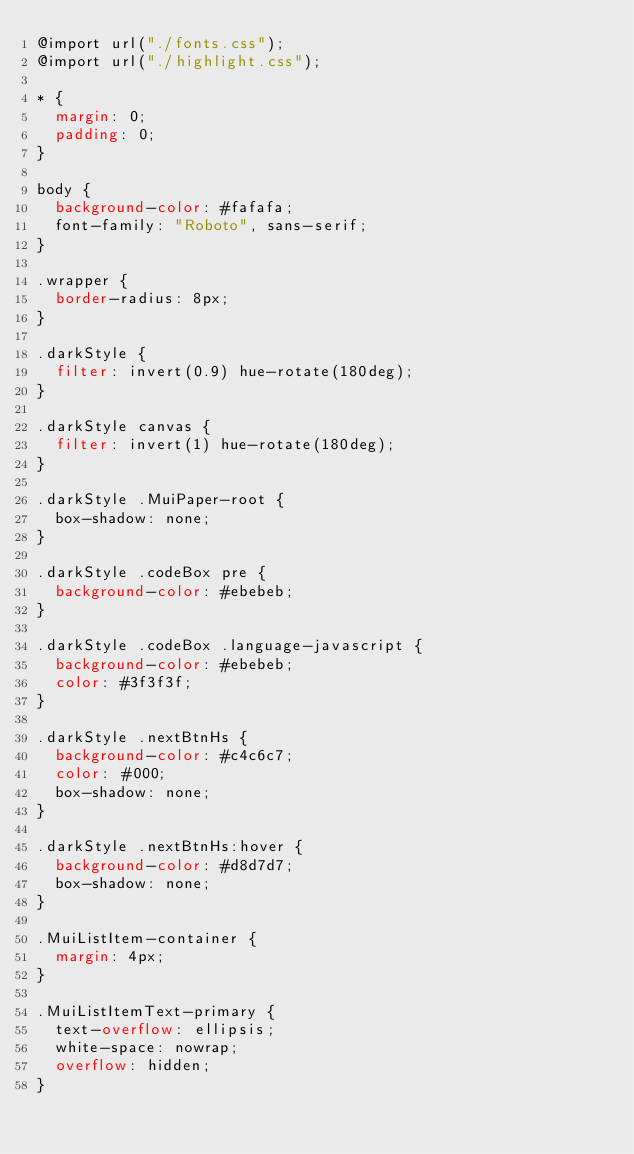Convert code to text. <code><loc_0><loc_0><loc_500><loc_500><_CSS_>@import url("./fonts.css");
@import url("./highlight.css");

* {
  margin: 0;
  padding: 0;
}

body {
  background-color: #fafafa;
  font-family: "Roboto", sans-serif;
}

.wrapper {
  border-radius: 8px;
}

.darkStyle {
  filter: invert(0.9) hue-rotate(180deg);
}

.darkStyle canvas {
  filter: invert(1) hue-rotate(180deg);
}

.darkStyle .MuiPaper-root {
  box-shadow: none;
}

.darkStyle .codeBox pre {
  background-color: #ebebeb;
}

.darkStyle .codeBox .language-javascript {
  background-color: #ebebeb;
  color: #3f3f3f;
}

.darkStyle .nextBtnHs {
  background-color: #c4c6c7;
  color: #000;
  box-shadow: none;
}

.darkStyle .nextBtnHs:hover {
  background-color: #d8d7d7;
  box-shadow: none;
}

.MuiListItem-container {
  margin: 4px;
}

.MuiListItemText-primary {
  text-overflow: ellipsis;
  white-space: nowrap;
  overflow: hidden;
}
</code> 